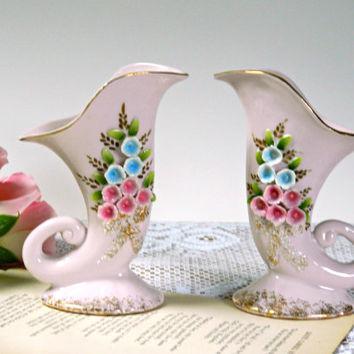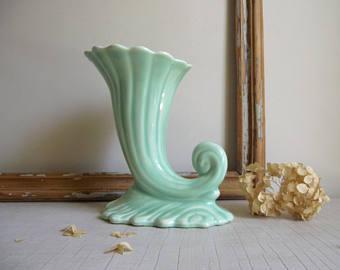The first image is the image on the left, the second image is the image on the right. For the images displayed, is the sentence "There is at least two vases in the right image." factually correct? Answer yes or no. No. The first image is the image on the left, the second image is the image on the right. Examine the images to the left and right. Is the description "An image shows a pair of vases designed with a curl shape at the bottom." accurate? Answer yes or no. Yes. 